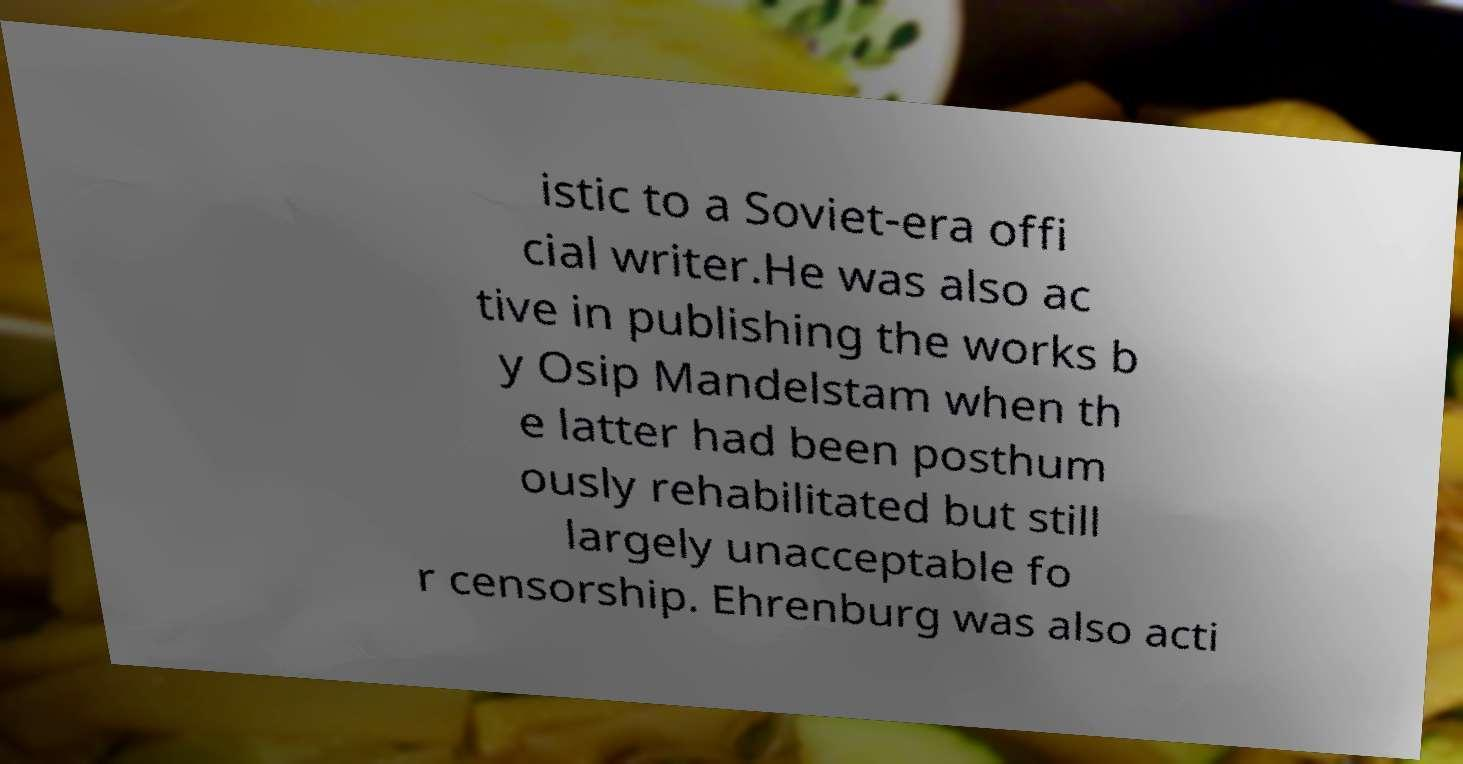Could you assist in decoding the text presented in this image and type it out clearly? istic to a Soviet-era offi cial writer.He was also ac tive in publishing the works b y Osip Mandelstam when th e latter had been posthum ously rehabilitated but still largely unacceptable fo r censorship. Ehrenburg was also acti 